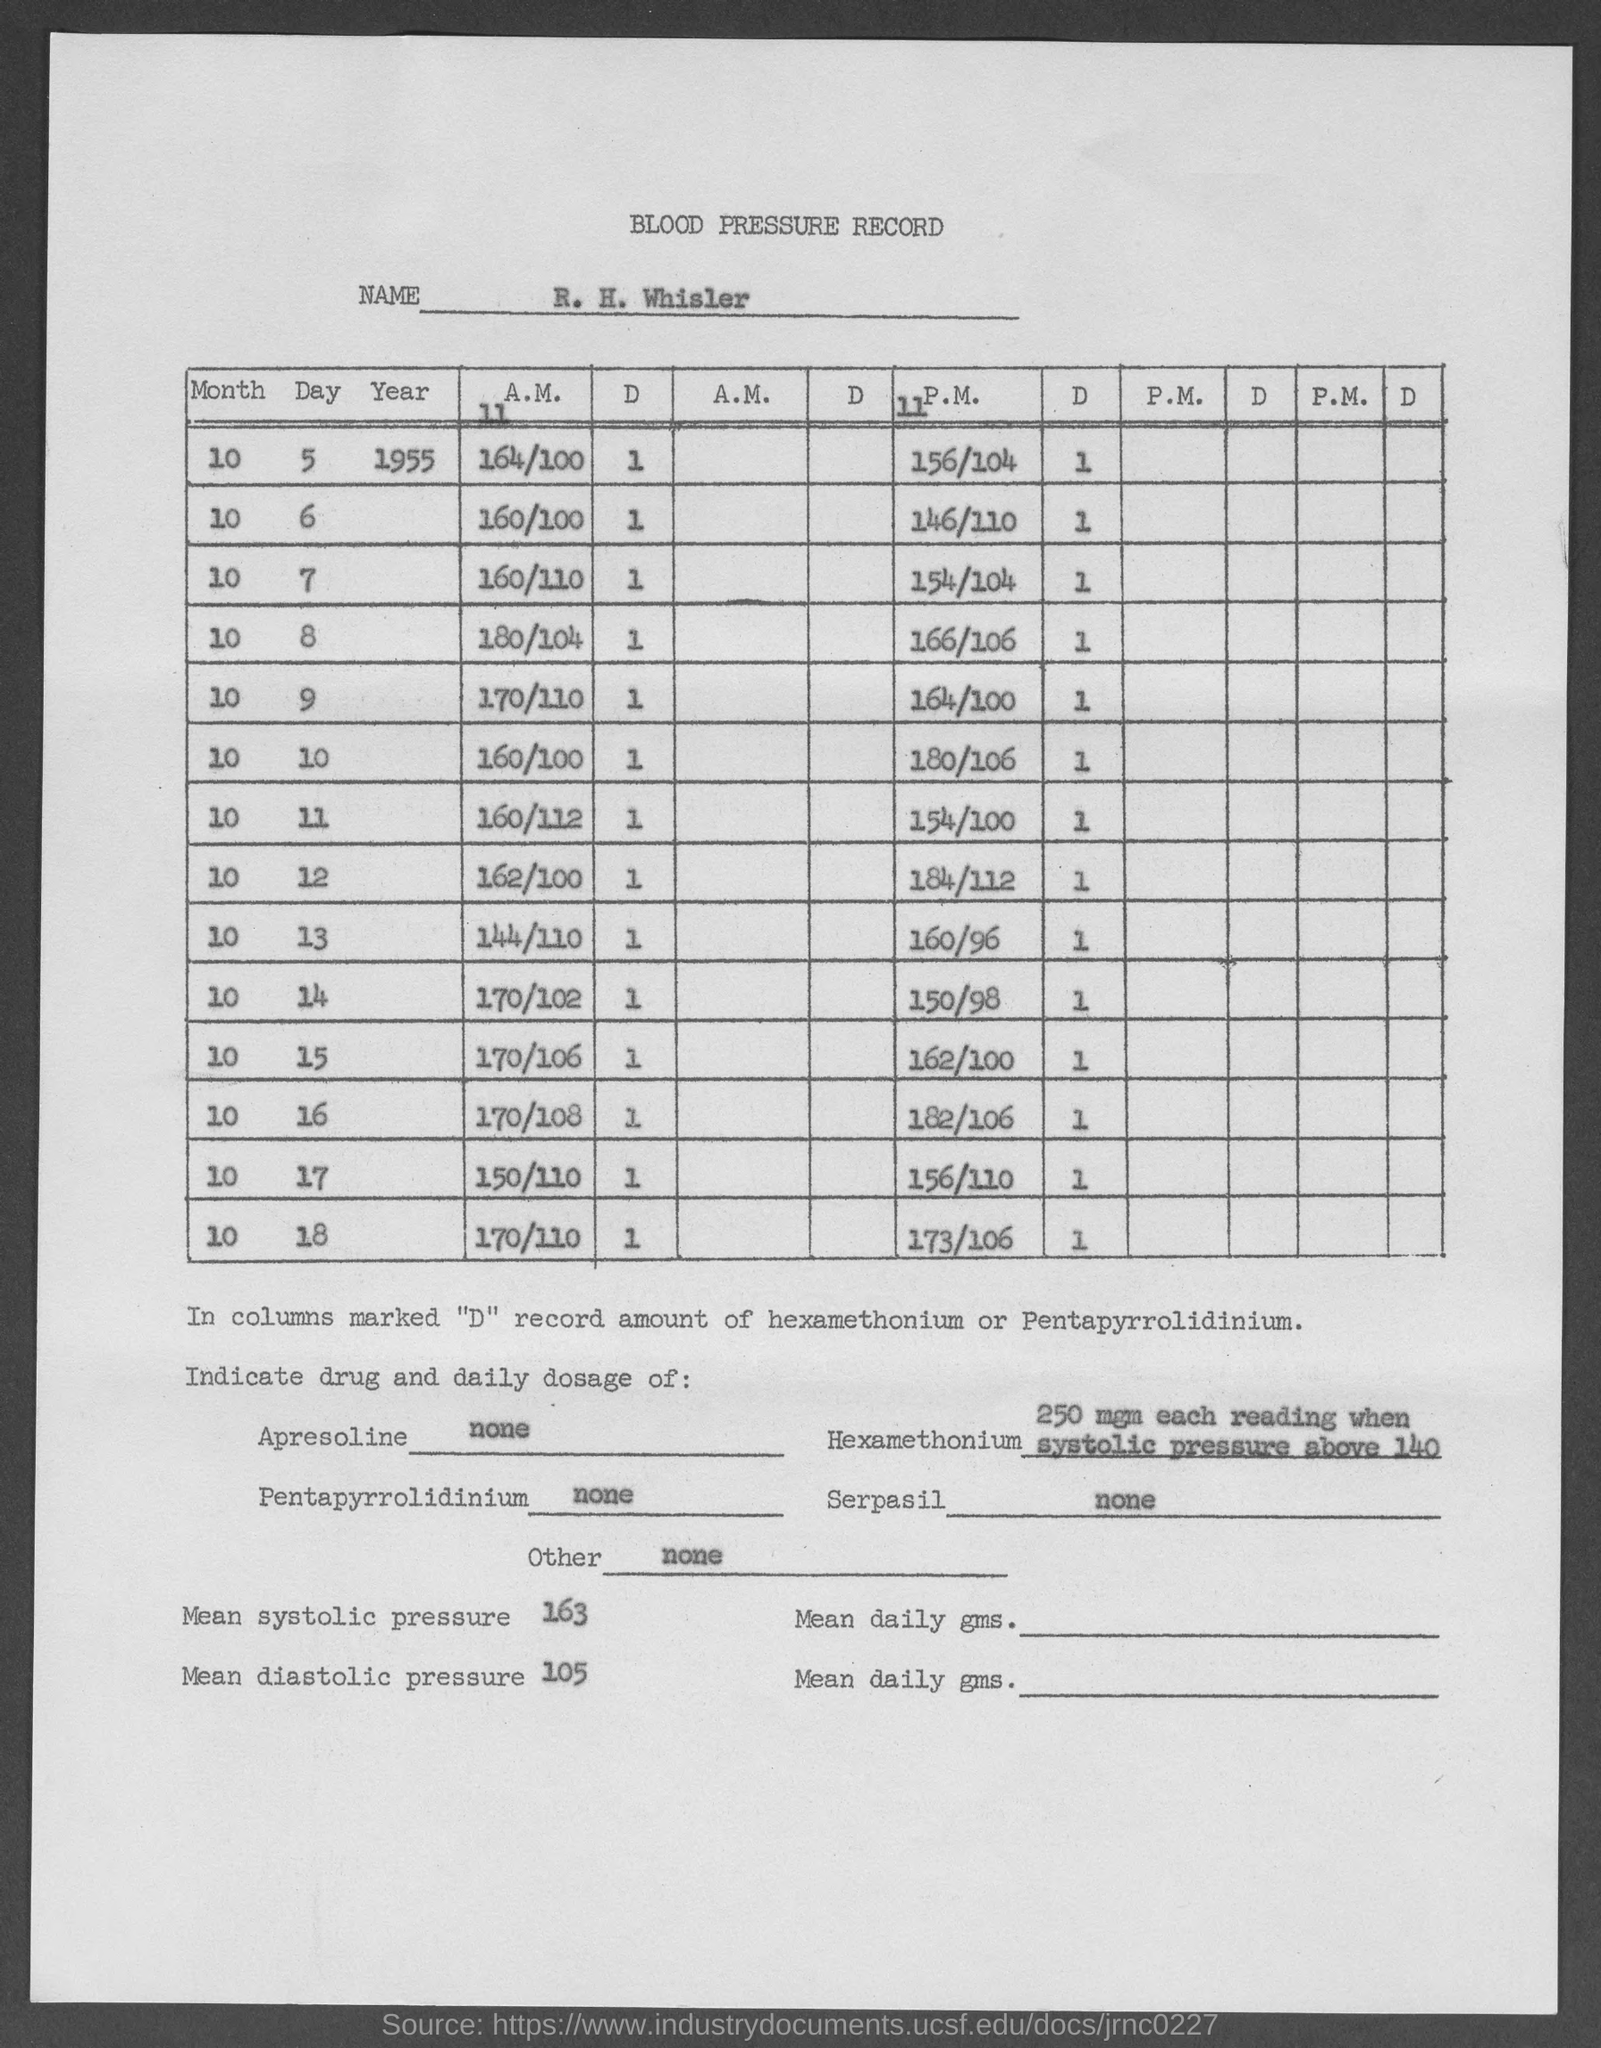Identify some key points in this picture. Based on the given record, the mean diastolic pressure is mentioned to be 105. The mean systolic pressure mentioned in the given record is 163. 